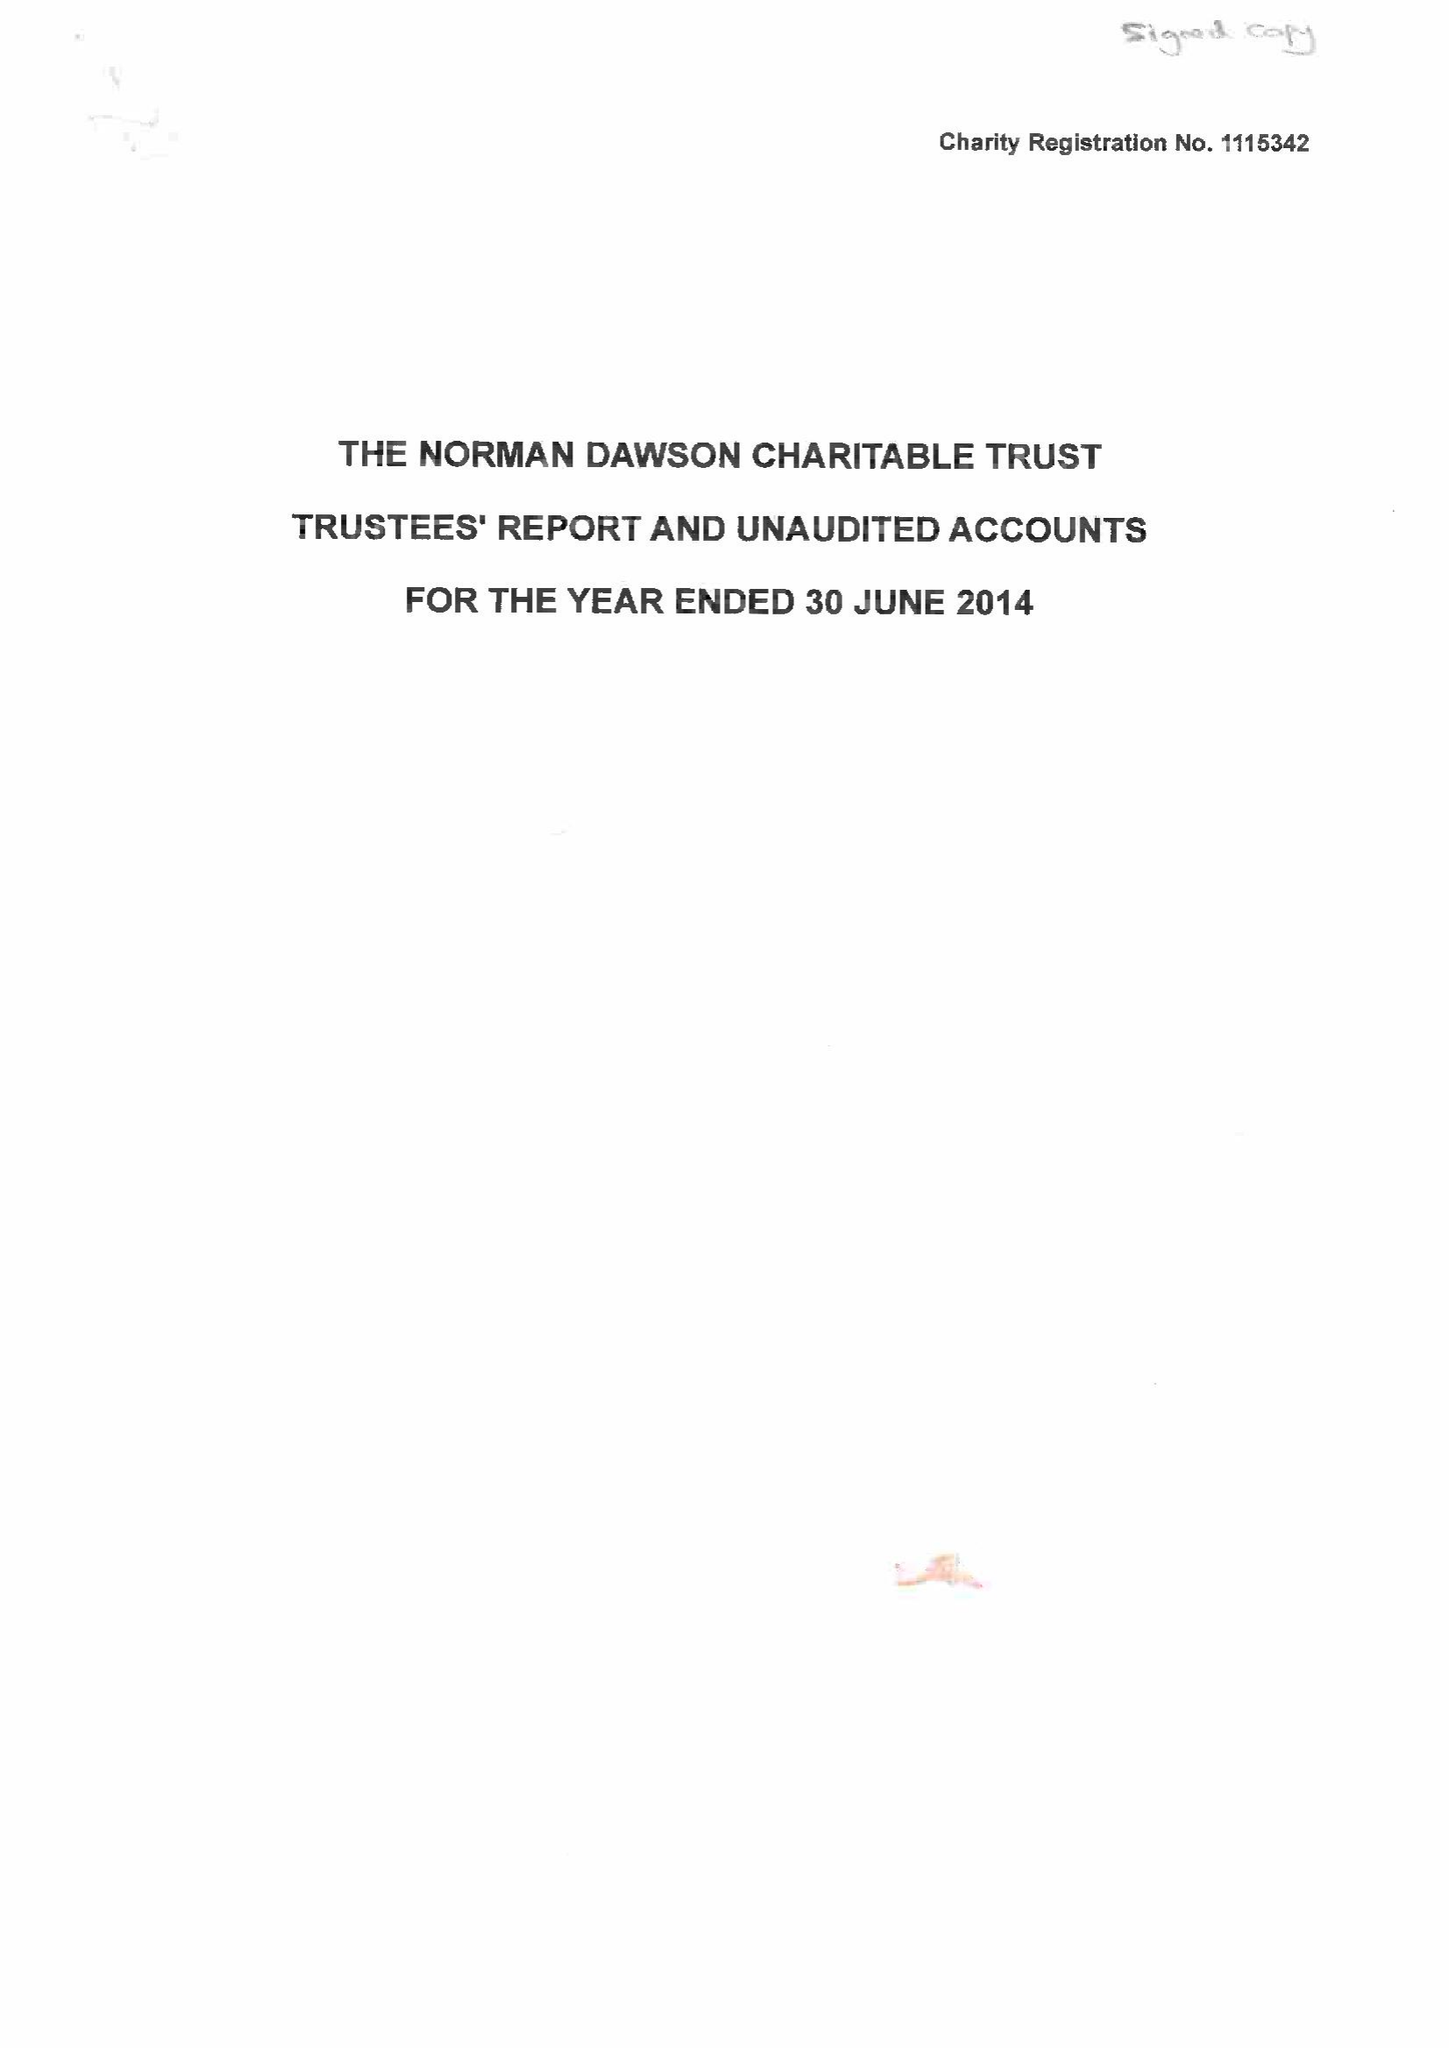What is the value for the charity_name?
Answer the question using a single word or phrase. The Norman Dawson Charitable Trust 